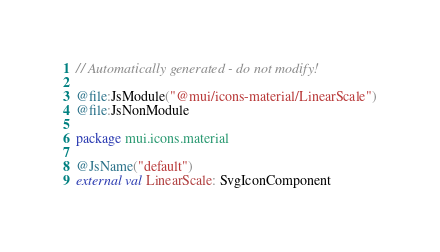<code> <loc_0><loc_0><loc_500><loc_500><_Kotlin_>// Automatically generated - do not modify!

@file:JsModule("@mui/icons-material/LinearScale")
@file:JsNonModule

package mui.icons.material

@JsName("default")
external val LinearScale: SvgIconComponent
</code> 